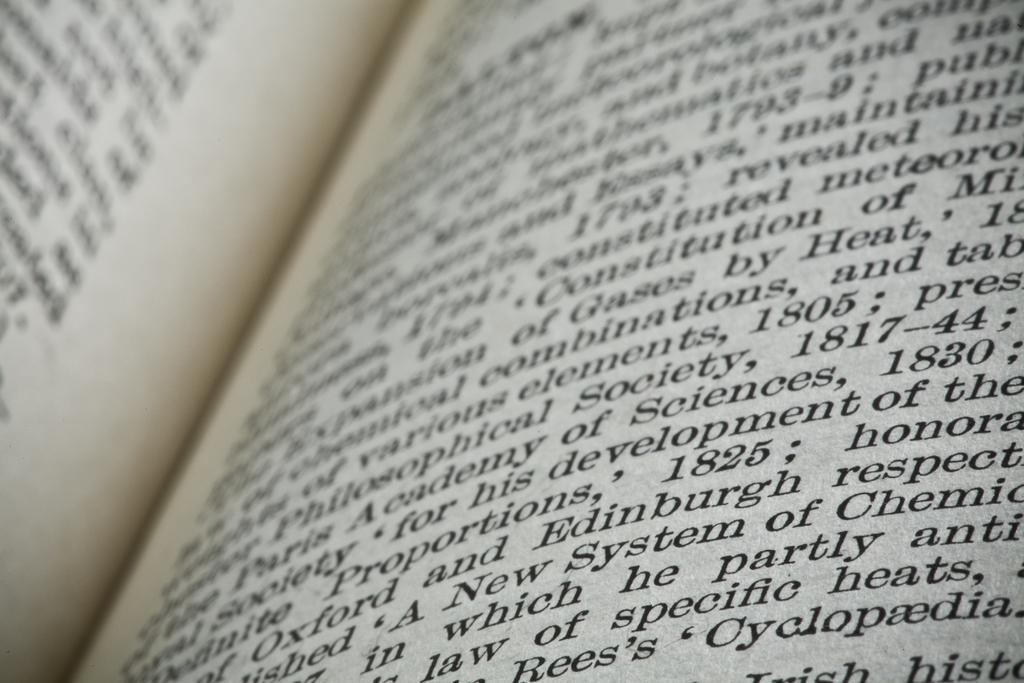<image>
Summarize the visual content of the image. A textbook is open to a page filled with words. some of the words are about specific heats. 